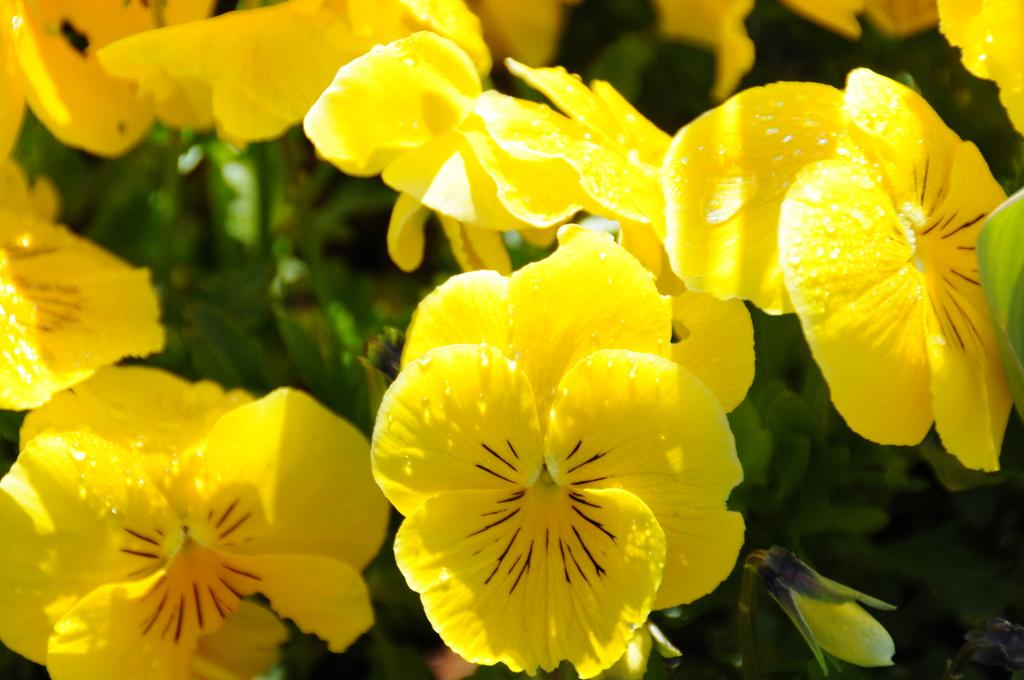What type of flowers can be seen in the image? There are yellow flowers in the image. What else can be seen in the background of the image? There are leaves visible in the background of the image. Can you see any veins in the honey in the image? There is no honey or veins present in the image; it features yellow flowers and leaves in the background. 